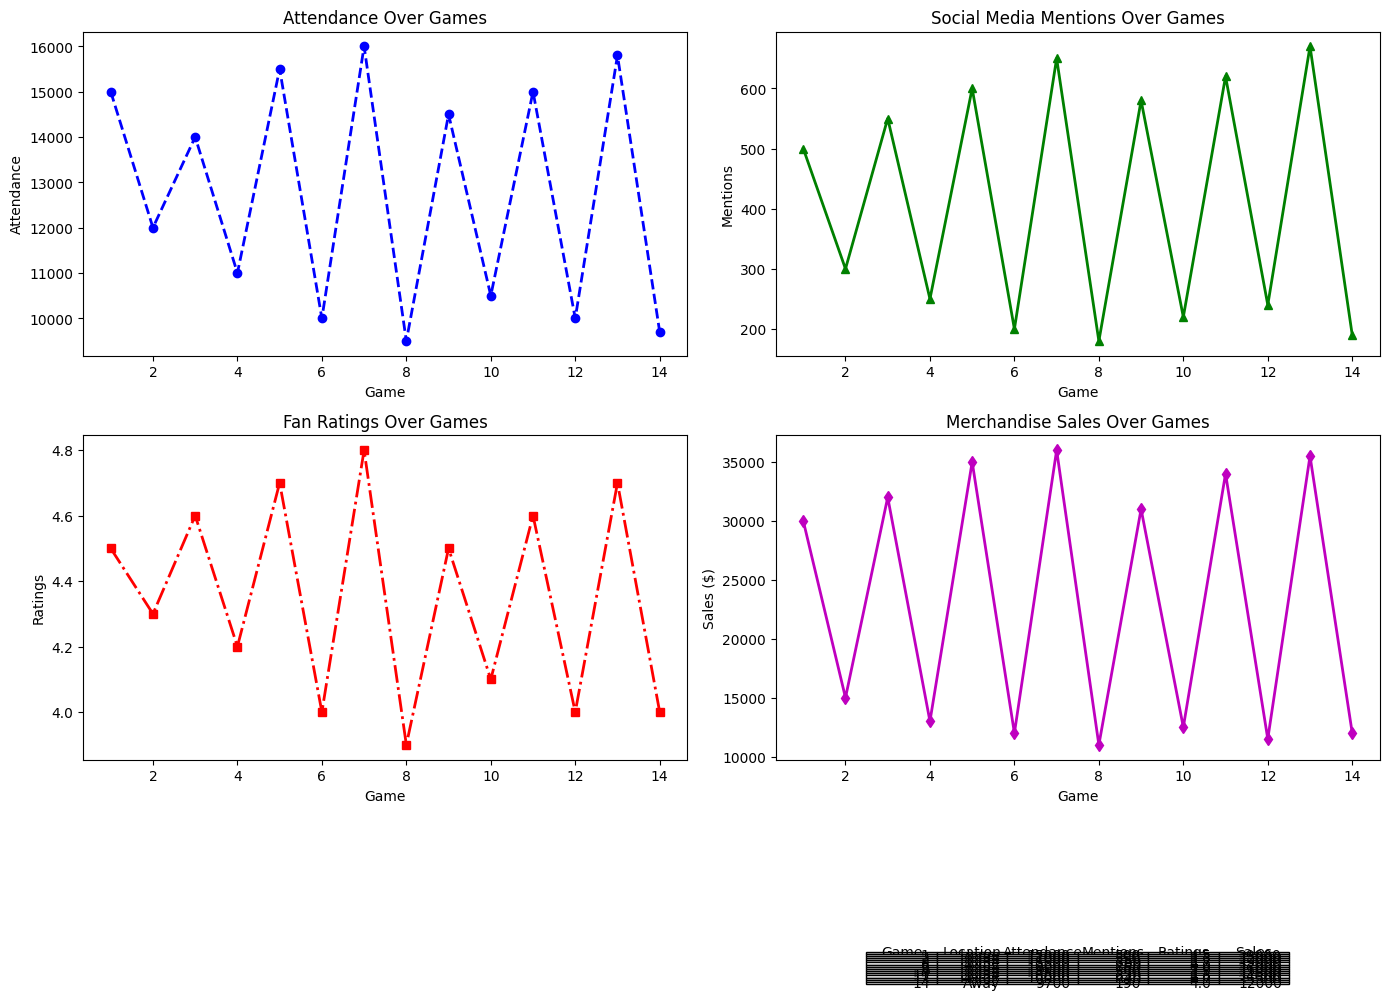What's the total attendance for home games? We sum all the attendance figures for the home games in the table: 15000 + 14000 + 15500 + 16000 + 14500 + 15000 + 15800 = 105800.
Answer: 105800 What is the difference in average fan ratings between home and away games? To find the average fan rating for each location, calculate: Home (4.5 + 4.6 + 4.7 + 4.8 + 4.5 + 4.6 + 4.7) / 7 = 4.62857; Away (4.3 + 4.2 + 4.0 + 3.9 + 4.1 + 4.0 + 4.0) / 7 = 4.07143. The difference is 4.62857 - 4.07143 ≈ 0.55714.
Answer: 0.557 Which game had the highest merchandise sales? By looking at the data for each game in the 'MerchSales' plot and table, Game 7 (Home) had the highest merchandise sales with $36000.
Answer: Game 7 How much higher was social media mentions for home games compared to away games on average? We calculate the average social media mentions for home and away games. Home: (500 + 550 + 600 + 650 + 580 + 620 + 670) / 7 = 595.71; Away: (300 + 250 + 200 + 180 + 220 + 240 + 190) / 7 = 225.71. The difference is 595.71 - 225.71 ≈ 370.
Answer: 370 How do attendance figures for game locations vary? Comparing the 'Attendance' plot for home and away games, home games generally have higher attendance than away games. For instance, the highest attendance at home is 16000 (Game 7), while the highest away attendance is 12000 (Game 2).
Answer: Home games have higher attendance Which game had the lowest fan rating, and what was its value? By examining the 'FanRatings' plot and table, the lowest fan rating was for Game 8 (Away) with a rating of 3.9.
Answer: Game 8, 3.9 Is there a trend between fan ratings and social media mentions? By visually inspecting both the 'FanRatings' and 'SocialMediaMentions' plots, it appears that higher fan ratings tend to correlate with more social media mentions. For example, Game 7 has the highest rating (4.8) and high mentions (650).
Answer: Yes, positive trend What's the total merchandise sales across all games? Summing all the merchandise sales from the table: 30000 + 15000 + 32000 + 13000 + 35000 + 12000 + 36000 + 11000 + 31000 + 12500 + 34000 + 11500 + 35500 + 12000 = 302500.
Answer: 302500 